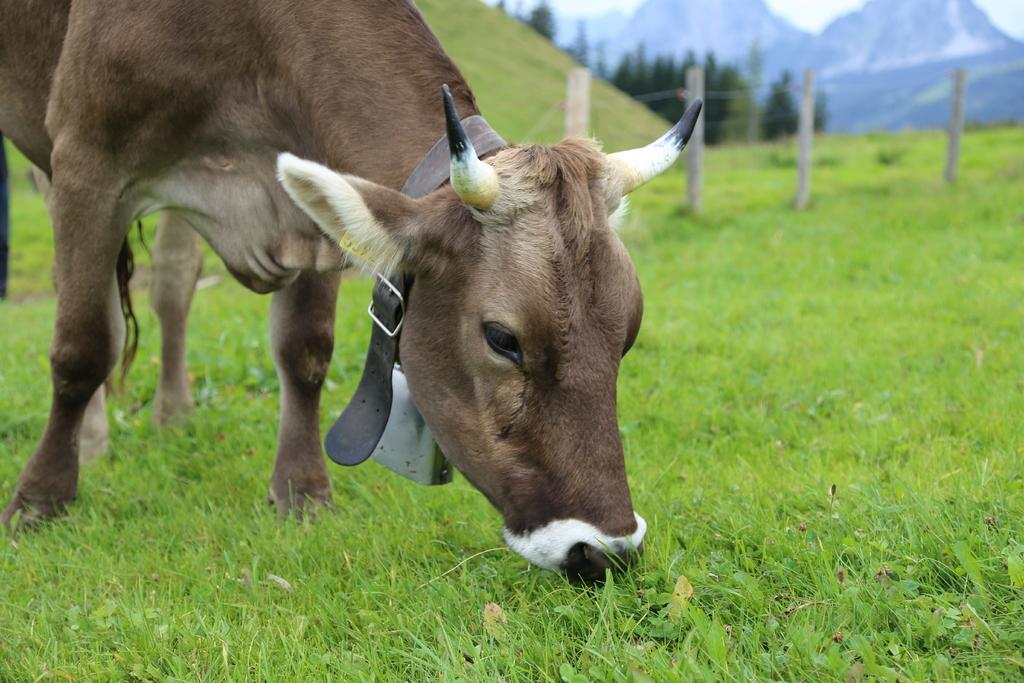What animal is present in the image? There is a cow in the image. What is the cow doing in the image? The cow is grazing the grass. What can be seen in the background of the image? There is a fence, trees, hills, mountains, and the sky visible in the background of the image. What language is the cow speaking in the image? Cows do not speak human languages, so there is no language spoken by the cow in the image. 